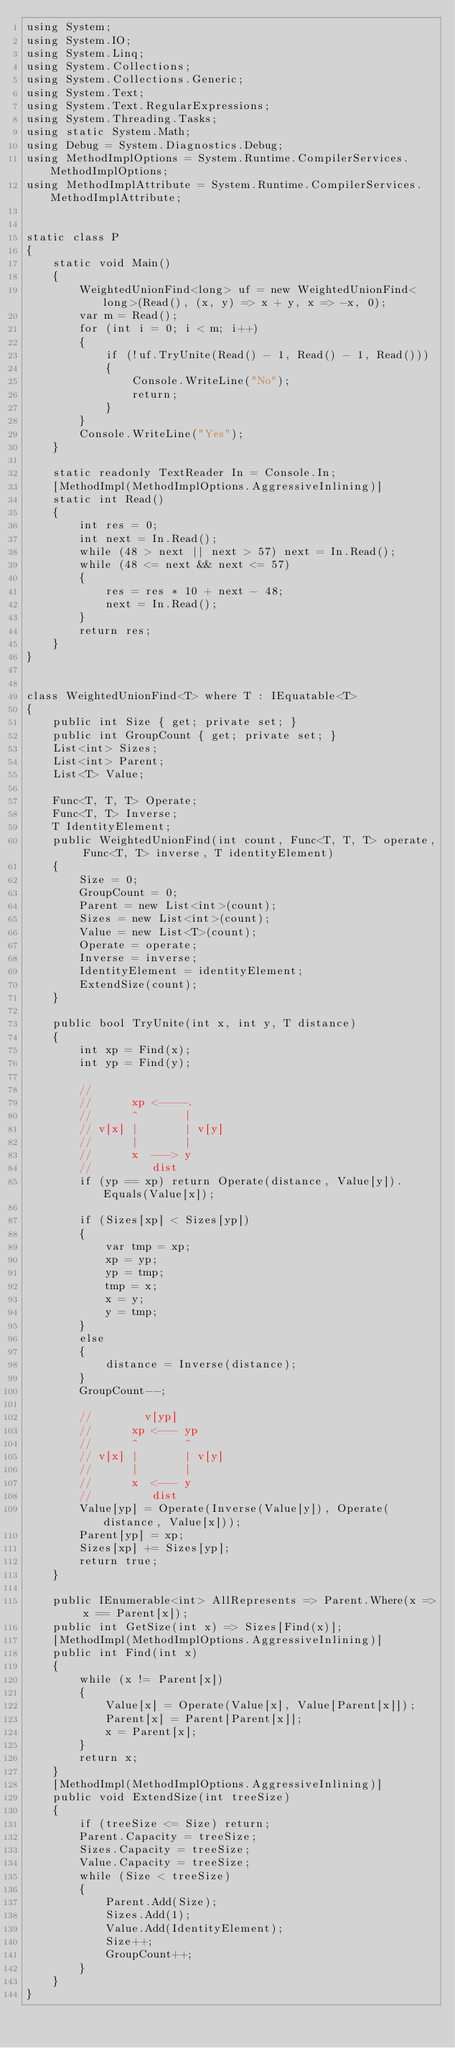<code> <loc_0><loc_0><loc_500><loc_500><_C#_>using System;
using System.IO;
using System.Linq;
using System.Collections;
using System.Collections.Generic;
using System.Text;
using System.Text.RegularExpressions;
using System.Threading.Tasks;
using static System.Math;
using Debug = System.Diagnostics.Debug;
using MethodImplOptions = System.Runtime.CompilerServices.MethodImplOptions;
using MethodImplAttribute = System.Runtime.CompilerServices.MethodImplAttribute;


static class P
{
    static void Main()
    {
        WeightedUnionFind<long> uf = new WeightedUnionFind<long>(Read(), (x, y) => x + y, x => -x, 0);
        var m = Read();
        for (int i = 0; i < m; i++)
        {
            if (!uf.TryUnite(Read() - 1, Read() - 1, Read()))
            {
                Console.WriteLine("No");
                return;
            }
        }
        Console.WriteLine("Yes");
    }

    static readonly TextReader In = Console.In;
    [MethodImpl(MethodImplOptions.AggressiveInlining)]
    static int Read()
    {
        int res = 0;
        int next = In.Read();
        while (48 > next || next > 57) next = In.Read();
        while (48 <= next && next <= 57)
        {
            res = res * 10 + next - 48;
            next = In.Read();
        }
        return res;
    }
}


class WeightedUnionFind<T> where T : IEquatable<T>
{
    public int Size { get; private set; }
    public int GroupCount { get; private set; }
    List<int> Sizes;
    List<int> Parent;
    List<T> Value;

    Func<T, T, T> Operate;
    Func<T, T> Inverse;
    T IdentityElement;
    public WeightedUnionFind(int count, Func<T, T, T> operate, Func<T, T> inverse, T identityElement)
    {
        Size = 0;
        GroupCount = 0;
        Parent = new List<int>(count);
        Sizes = new List<int>(count);
        Value = new List<T>(count);
        Operate = operate;
        Inverse = inverse;
        IdentityElement = identityElement;
        ExtendSize(count);
    }

    public bool TryUnite(int x, int y, T distance)
    {
        int xp = Find(x);
        int yp = Find(y);

        //        
        //      xp <----.
        //      ^       |
        // v[x] |       | v[y]
        //      |       |
        //      x  ---> y
        //         dist
        if (yp == xp) return Operate(distance, Value[y]).Equals(Value[x]);

        if (Sizes[xp] < Sizes[yp])
        {
            var tmp = xp;
            xp = yp;
            yp = tmp;
            tmp = x;
            x = y;
            y = tmp;
        }
        else
        {
            distance = Inverse(distance);
        }
        GroupCount--;

        //        v[yp]
        //      xp <--- yp
        //      ^       ^
        // v[x] |       | v[y]
        //      |       |
        //      x  <--- y
        //         dist
        Value[yp] = Operate(Inverse(Value[y]), Operate(distance, Value[x]));
        Parent[yp] = xp;
        Sizes[xp] += Sizes[yp];
        return true;
    }

    public IEnumerable<int> AllRepresents => Parent.Where(x => x == Parent[x]);
    public int GetSize(int x) => Sizes[Find(x)];
    [MethodImpl(MethodImplOptions.AggressiveInlining)]
    public int Find(int x)
    {
        while (x != Parent[x])
        {
            Value[x] = Operate(Value[x], Value[Parent[x]]);
            Parent[x] = Parent[Parent[x]];
            x = Parent[x];
        }
        return x;
    }
    [MethodImpl(MethodImplOptions.AggressiveInlining)]
    public void ExtendSize(int treeSize)
    {
        if (treeSize <= Size) return;
        Parent.Capacity = treeSize;
        Sizes.Capacity = treeSize;
        Value.Capacity = treeSize;
        while (Size < treeSize)
        {
            Parent.Add(Size);
            Sizes.Add(1);
            Value.Add(IdentityElement);
            Size++;
            GroupCount++;
        }
    }
}
</code> 